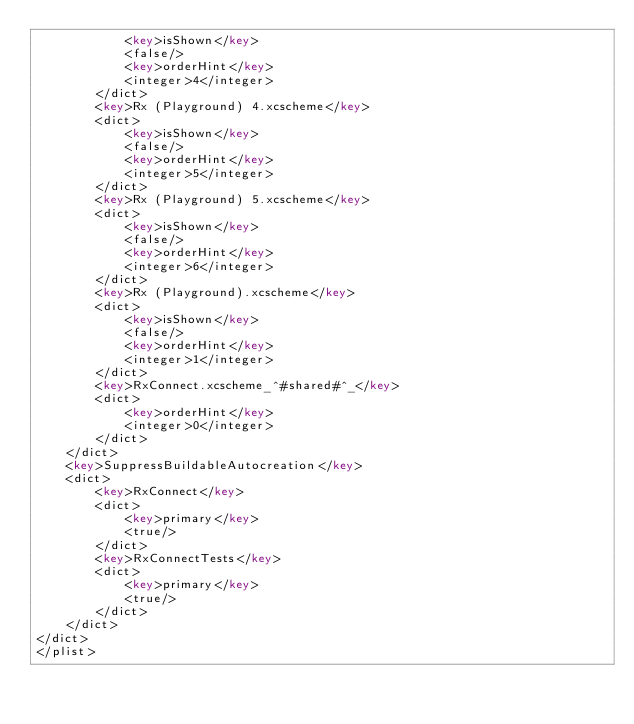<code> <loc_0><loc_0><loc_500><loc_500><_XML_>			<key>isShown</key>
			<false/>
			<key>orderHint</key>
			<integer>4</integer>
		</dict>
		<key>Rx (Playground) 4.xcscheme</key>
		<dict>
			<key>isShown</key>
			<false/>
			<key>orderHint</key>
			<integer>5</integer>
		</dict>
		<key>Rx (Playground) 5.xcscheme</key>
		<dict>
			<key>isShown</key>
			<false/>
			<key>orderHint</key>
			<integer>6</integer>
		</dict>
		<key>Rx (Playground).xcscheme</key>
		<dict>
			<key>isShown</key>
			<false/>
			<key>orderHint</key>
			<integer>1</integer>
		</dict>
		<key>RxConnect.xcscheme_^#shared#^_</key>
		<dict>
			<key>orderHint</key>
			<integer>0</integer>
		</dict>
	</dict>
	<key>SuppressBuildableAutocreation</key>
	<dict>
		<key>RxConnect</key>
		<dict>
			<key>primary</key>
			<true/>
		</dict>
		<key>RxConnectTests</key>
		<dict>
			<key>primary</key>
			<true/>
		</dict>
	</dict>
</dict>
</plist>
</code> 